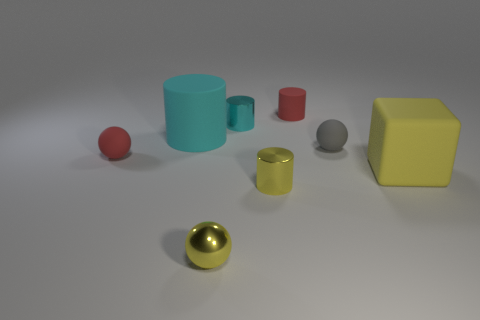Subtract all small yellow shiny cylinders. How many cylinders are left? 3 Subtract all yellow blocks. How many cyan cylinders are left? 2 Subtract all spheres. How many objects are left? 5 Add 2 big gray rubber blocks. How many objects exist? 10 Subtract all red cylinders. How many cylinders are left? 3 Subtract 2 balls. How many balls are left? 1 Add 2 cyan objects. How many cyan objects are left? 4 Add 7 yellow objects. How many yellow objects exist? 10 Subtract 0 blue blocks. How many objects are left? 8 Subtract all green spheres. Subtract all green cylinders. How many spheres are left? 3 